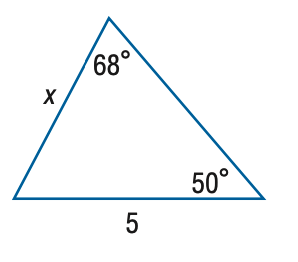Question: Find x. Round side measure to the nearest tenth.
Choices:
A. 4.1
B. 4.8
C. 5.3
D. 6.1
Answer with the letter. Answer: A 